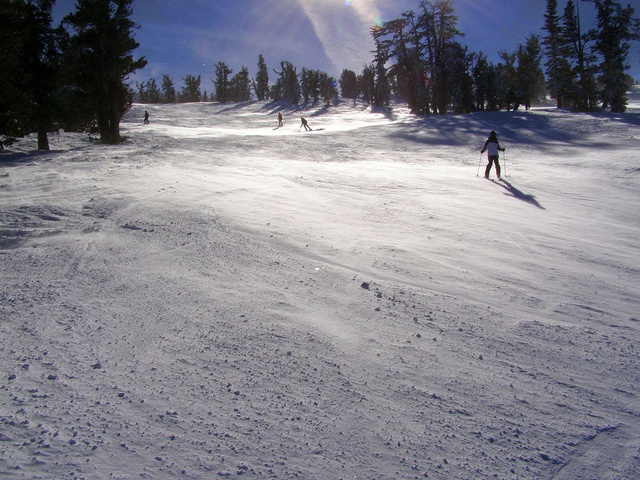Describe the objects in this image and their specific colors. I can see people in black, gray, navy, and purple tones, people in black, gray, darkgray, and lightgray tones, people in black, gray, purple, and darkgreen tones, people in black, gray, and maroon tones, and skis in black, gray, and purple tones in this image. 